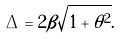<formula> <loc_0><loc_0><loc_500><loc_500>\Delta = 2 \beta \sqrt { 1 + \theta ^ { 2 } } .</formula> 